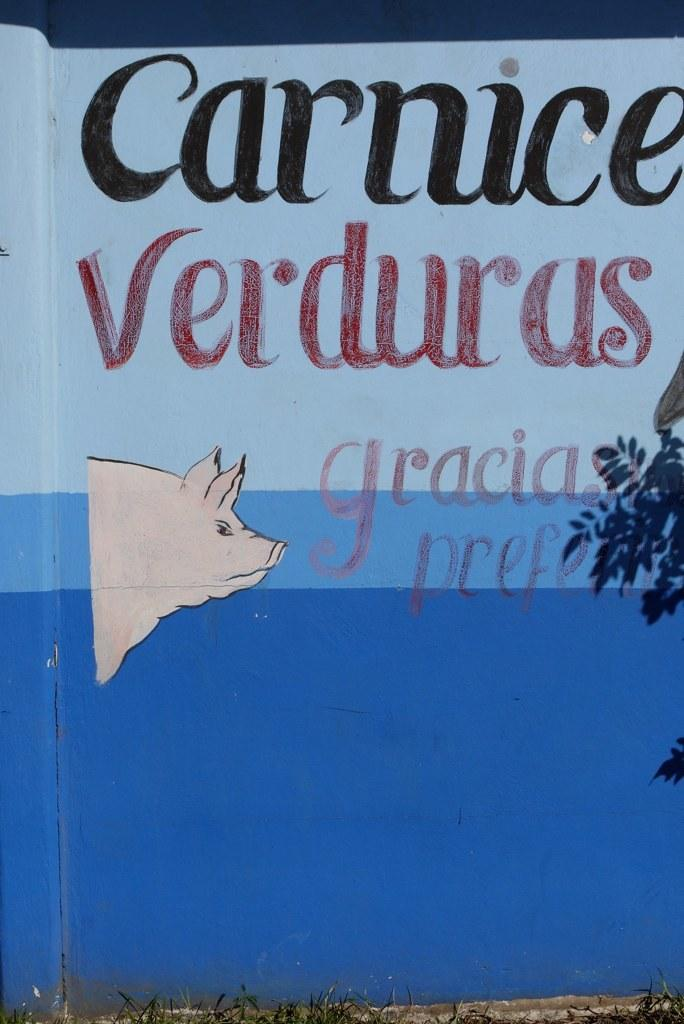What is the main object in the image? There is a board in the image. What can be found on the board? There is text and a picture of a pig on the board. How does the expert use their memory to recall information about the board? There is no expert present in the image, and the image does not depict any memory or recall process. 